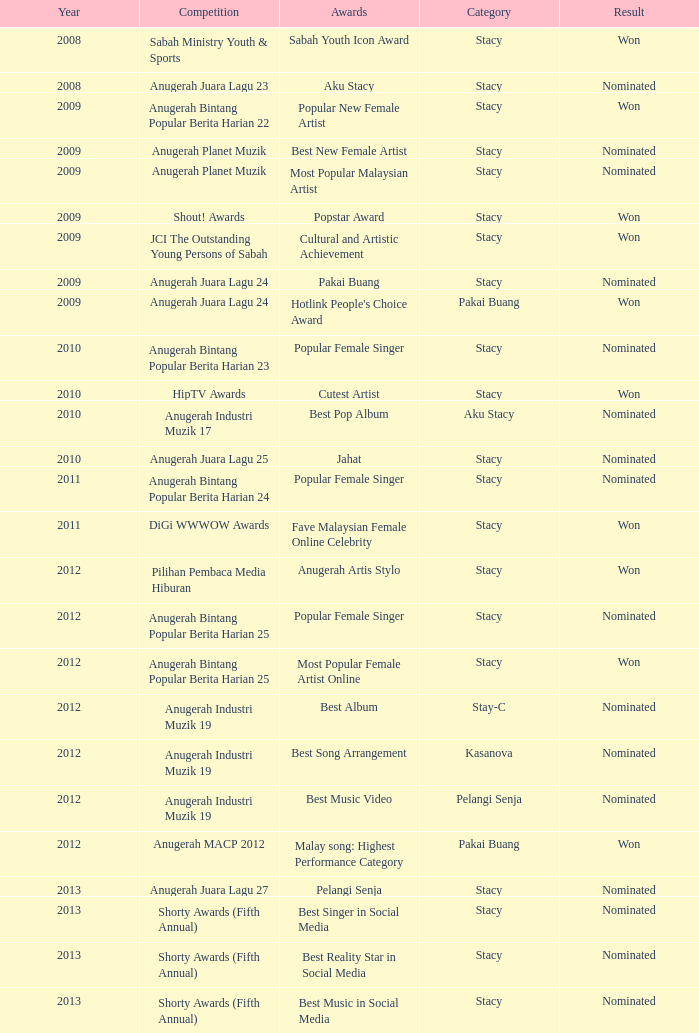Would you mind parsing the complete table? {'header': ['Year', 'Competition', 'Awards', 'Category', 'Result'], 'rows': [['2008', 'Sabah Ministry Youth & Sports', 'Sabah Youth Icon Award', 'Stacy', 'Won'], ['2008', 'Anugerah Juara Lagu 23', 'Aku Stacy', 'Stacy', 'Nominated'], ['2009', 'Anugerah Bintang Popular Berita Harian 22', 'Popular New Female Artist', 'Stacy', 'Won'], ['2009', 'Anugerah Planet Muzik', 'Best New Female Artist', 'Stacy', 'Nominated'], ['2009', 'Anugerah Planet Muzik', 'Most Popular Malaysian Artist', 'Stacy', 'Nominated'], ['2009', 'Shout! Awards', 'Popstar Award', 'Stacy', 'Won'], ['2009', 'JCI The Outstanding Young Persons of Sabah', 'Cultural and Artistic Achievement', 'Stacy', 'Won'], ['2009', 'Anugerah Juara Lagu 24', 'Pakai Buang', 'Stacy', 'Nominated'], ['2009', 'Anugerah Juara Lagu 24', "Hotlink People's Choice Award", 'Pakai Buang', 'Won'], ['2010', 'Anugerah Bintang Popular Berita Harian 23', 'Popular Female Singer', 'Stacy', 'Nominated'], ['2010', 'HipTV Awards', 'Cutest Artist', 'Stacy', 'Won'], ['2010', 'Anugerah Industri Muzik 17', 'Best Pop Album', 'Aku Stacy', 'Nominated'], ['2010', 'Anugerah Juara Lagu 25', 'Jahat', 'Stacy', 'Nominated'], ['2011', 'Anugerah Bintang Popular Berita Harian 24', 'Popular Female Singer', 'Stacy', 'Nominated'], ['2011', 'DiGi WWWOW Awards', 'Fave Malaysian Female Online Celebrity', 'Stacy', 'Won'], ['2012', 'Pilihan Pembaca Media Hiburan', 'Anugerah Artis Stylo', 'Stacy', 'Won'], ['2012', 'Anugerah Bintang Popular Berita Harian 25', 'Popular Female Singer', 'Stacy', 'Nominated'], ['2012', 'Anugerah Bintang Popular Berita Harian 25', 'Most Popular Female Artist Online', 'Stacy', 'Won'], ['2012', 'Anugerah Industri Muzik 19', 'Best Album', 'Stay-C', 'Nominated'], ['2012', 'Anugerah Industri Muzik 19', 'Best Song Arrangement', 'Kasanova', 'Nominated'], ['2012', 'Anugerah Industri Muzik 19', 'Best Music Video', 'Pelangi Senja', 'Nominated'], ['2012', 'Anugerah MACP 2012', 'Malay song: Highest Performance Category', 'Pakai Buang', 'Won'], ['2013', 'Anugerah Juara Lagu 27', 'Pelangi Senja', 'Stacy', 'Nominated'], ['2013', 'Shorty Awards (Fifth Annual)', 'Best Singer in Social Media', 'Stacy', 'Nominated'], ['2013', 'Shorty Awards (Fifth Annual)', 'Best Reality Star in Social Media', 'Stacy', 'Nominated'], ['2013', 'Shorty Awards (Fifth Annual)', 'Best Music in Social Media', 'Stacy', 'Nominated']]} Which award was presented in the year following 2009 and involved the digi wwwow awards competition? Fave Malaysian Female Online Celebrity. 